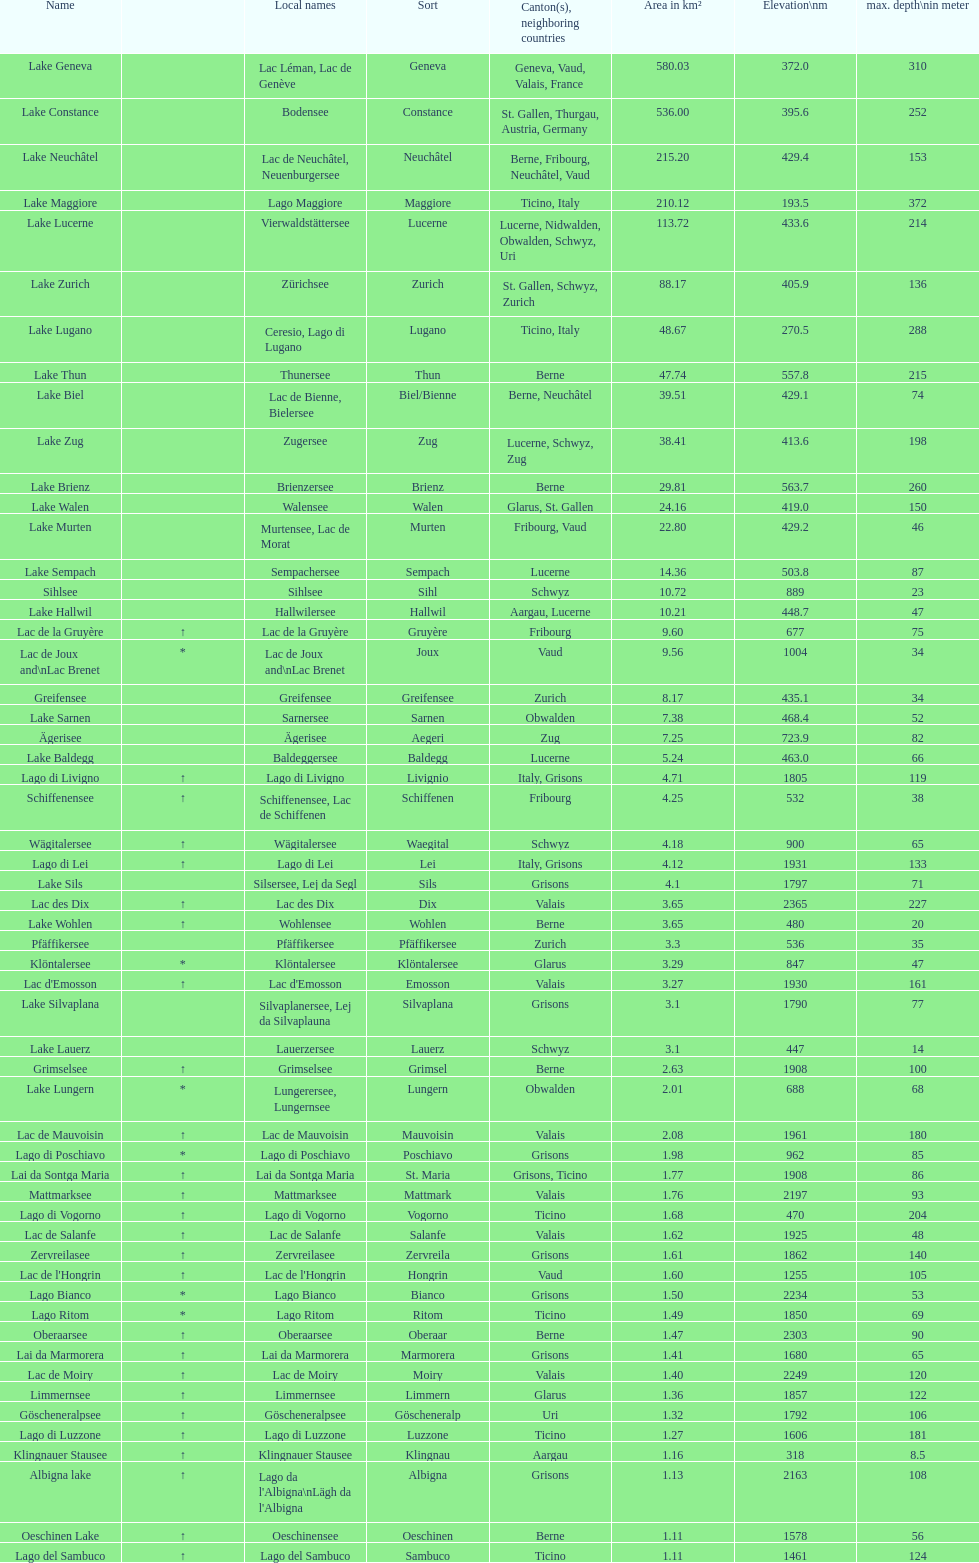What is the total deepest point of lake geneva and lake constance combined? 562. 